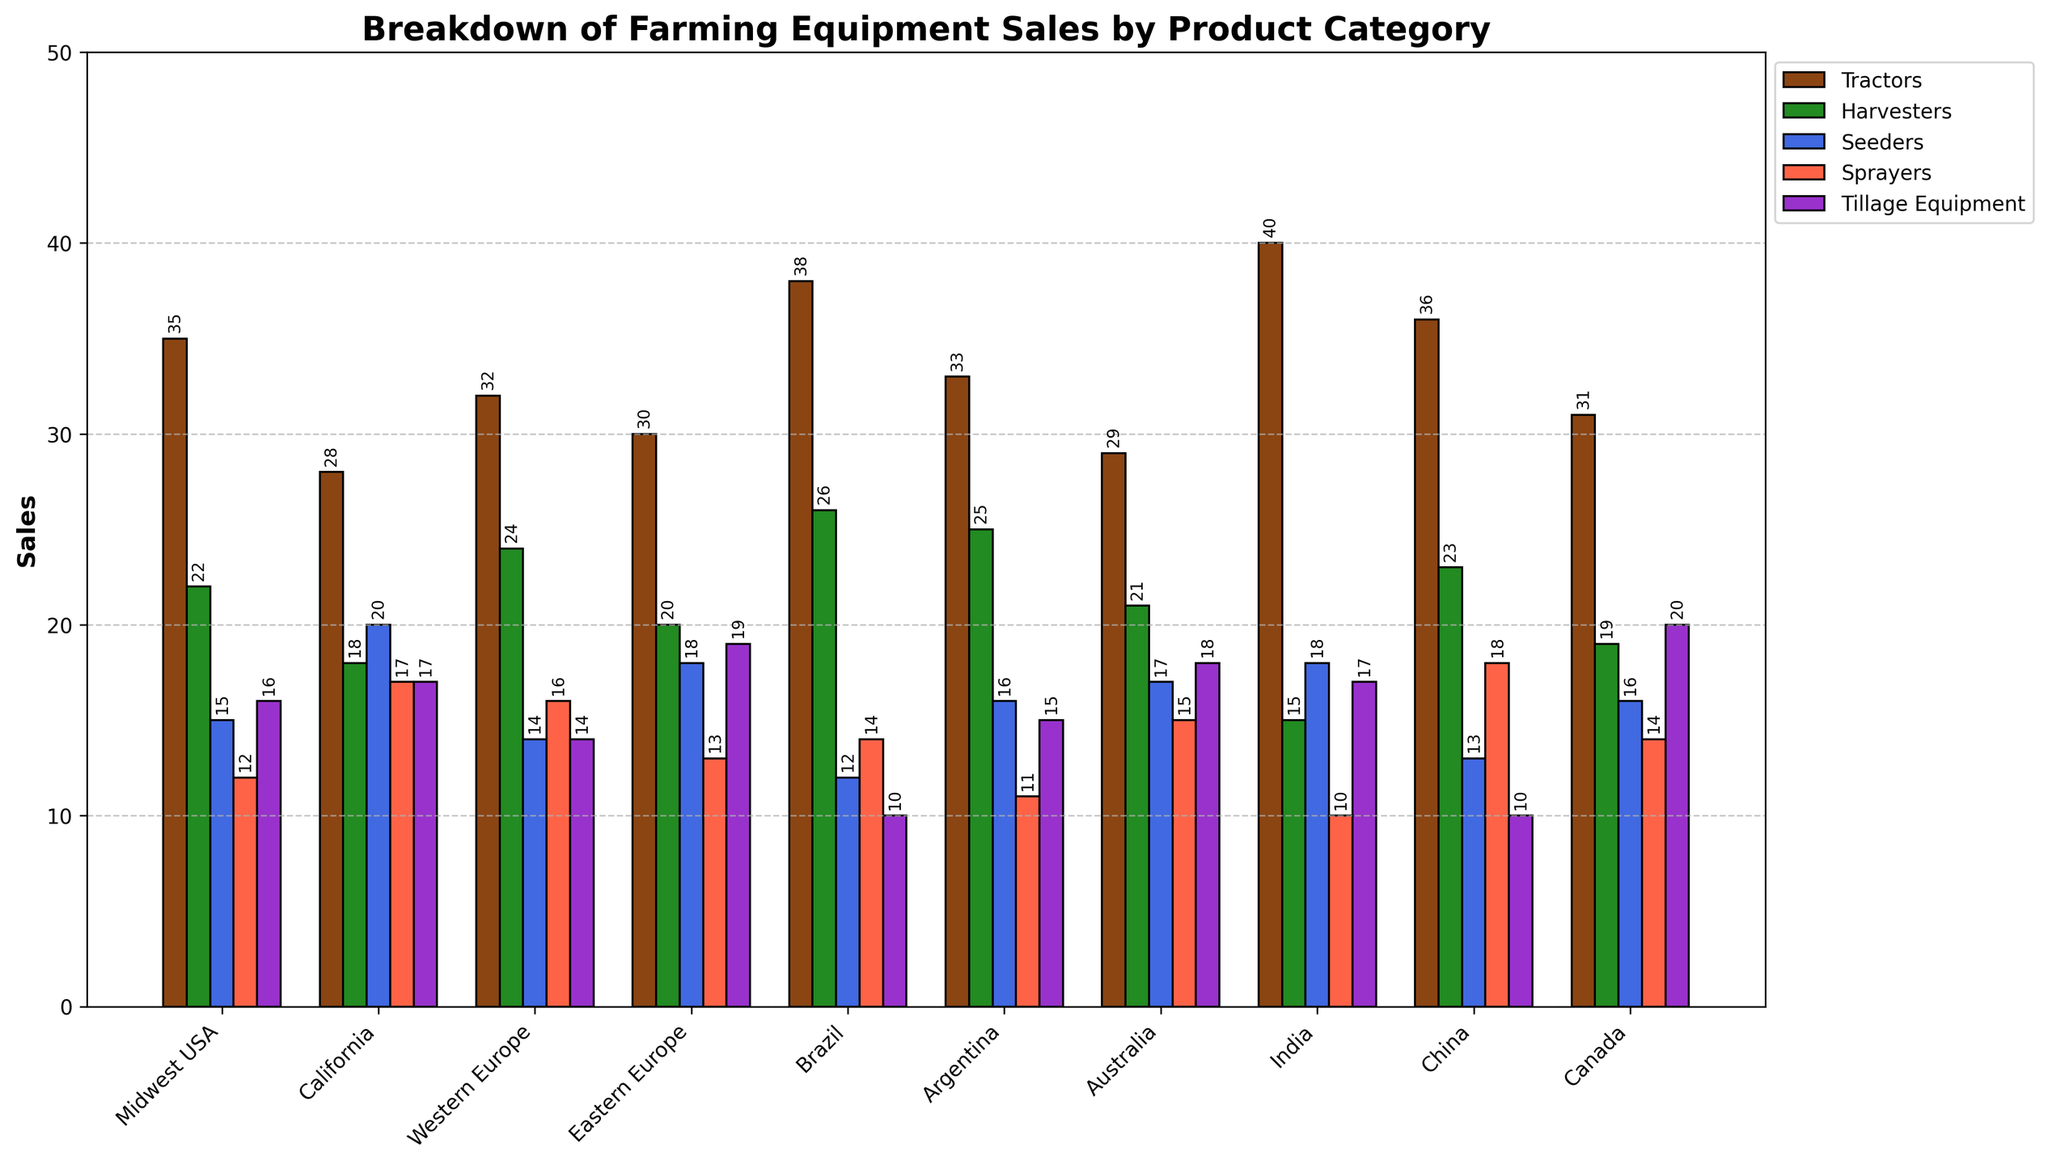Which region has the highest sales of Tractors? By observing the heights of the bars for each region under the 'Tractors' category, which are brown in color, it's clear that India has the highest bar for Tractors.
Answer: India Which product category has the lowest sales in China? By examining the heights of the bars in the China column, the lowest bar corresponds to the Tillage Equipment category.
Answer: Tillage Equipment Are tractor sales higher in Brazil or California? Compare the height of the brown bars in the columns for Brazil and California. The brown bar is higher in Brazil than in California.
Answer: Brazil What is the total sales for Harvesters in Midwest USA and Argentina combined? Add the sales of Harvesters from Midwest USA (22) and Argentina (25). So, 22 + 25 = 47.
Answer: 47 Which product category has the most uniform sales across all regions? By visually assessing the consistency of the heights of the bars across all regions, Sprayers (red bars) appear to be the most uniform in height.
Answer: Sprayers What is the average sales of Seeders in all regions? Sum the sales of Seeders in all regions (15 + 20 + 14 + 18 + 12 + 16 + 17 + 18 + 13 + 16 = 159) and divide by the number of regions (10). Hence, 159/10 = 15.9.
Answer: 15.9 Is there a region where Sprayers are sold more than Seeders? If yes, name one. By comparing the heights of the red and blue bars within each region, California is one example where Sprayers (17) are sold more than Seeders (20).
Answer: California What is the difference in sales of Tillage Equipment between Eastern Europe and Canada? Subtract the sales of Tillage Equipment in Eastern Europe (19) from the sales in Canada (20). So, 20 - 19 = 1.
Answer: 1 